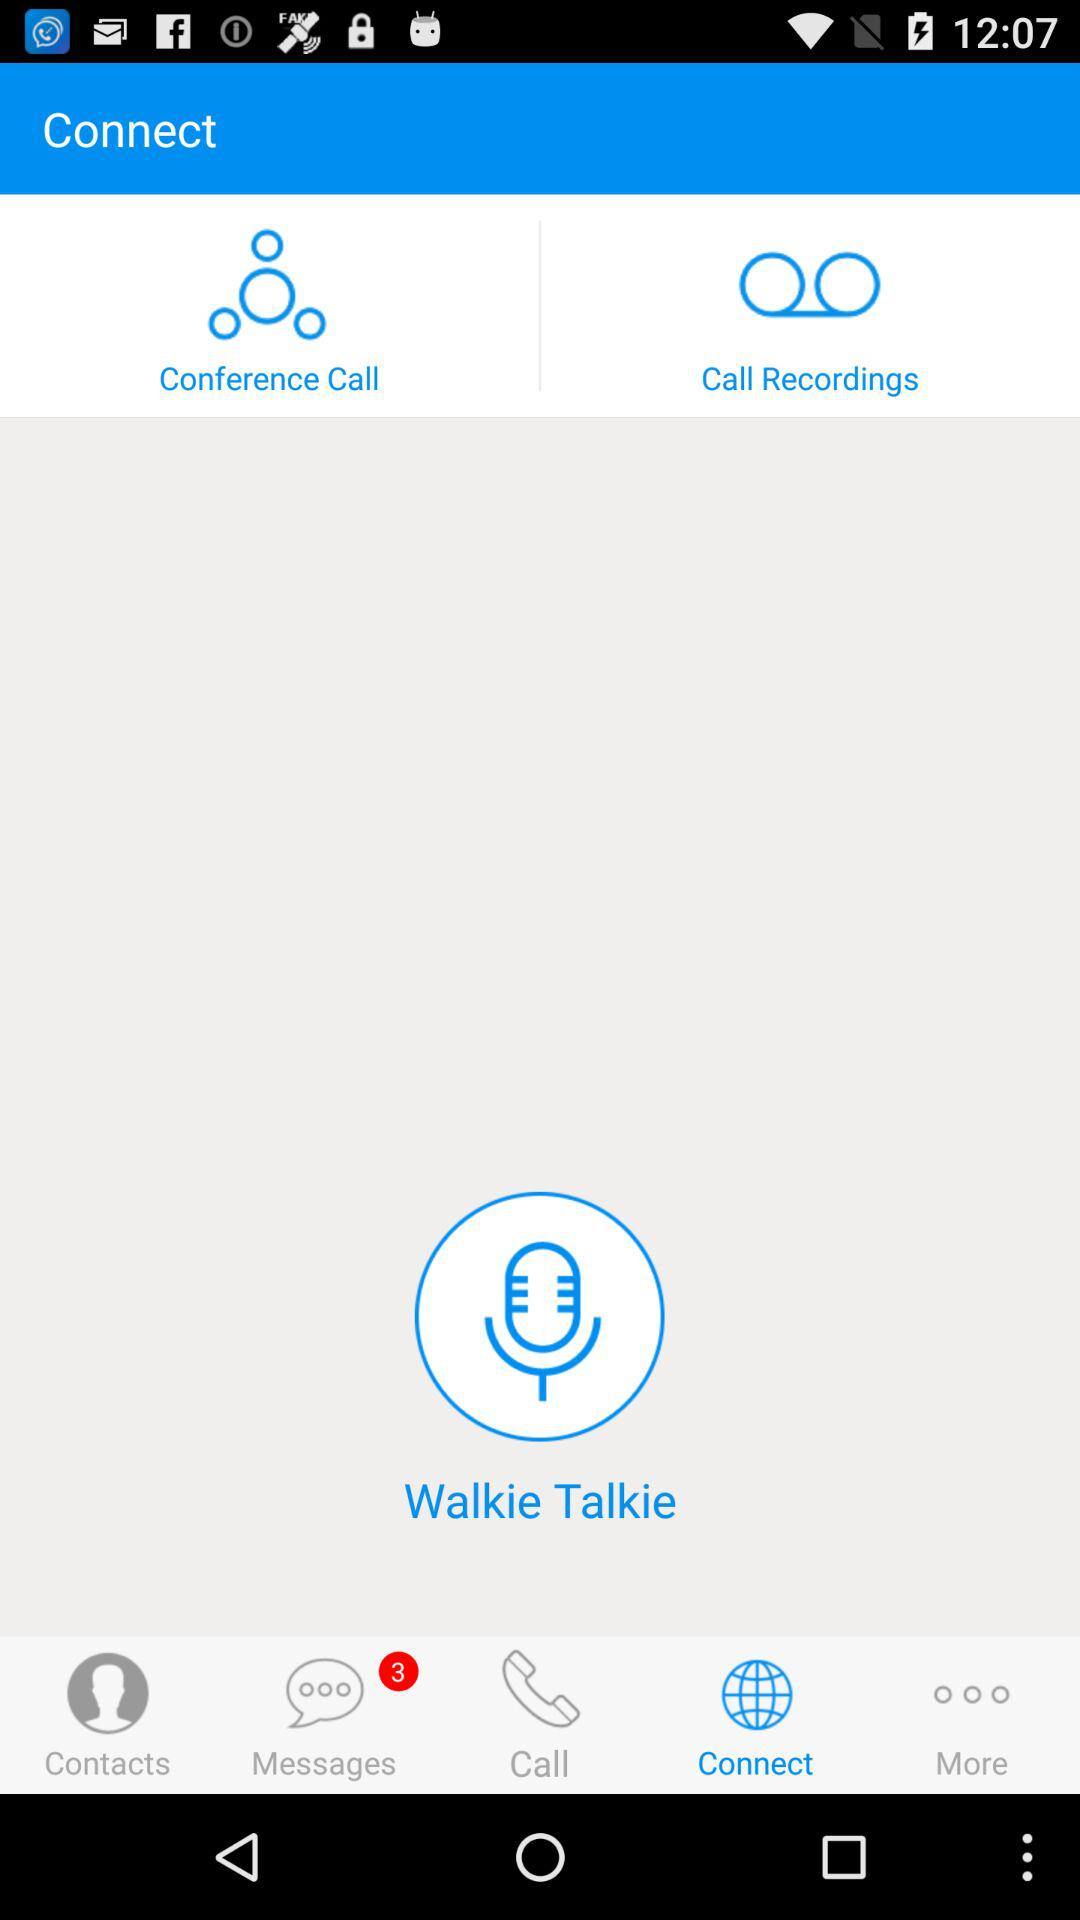How many messages are unread? There are 3 unread messages. 